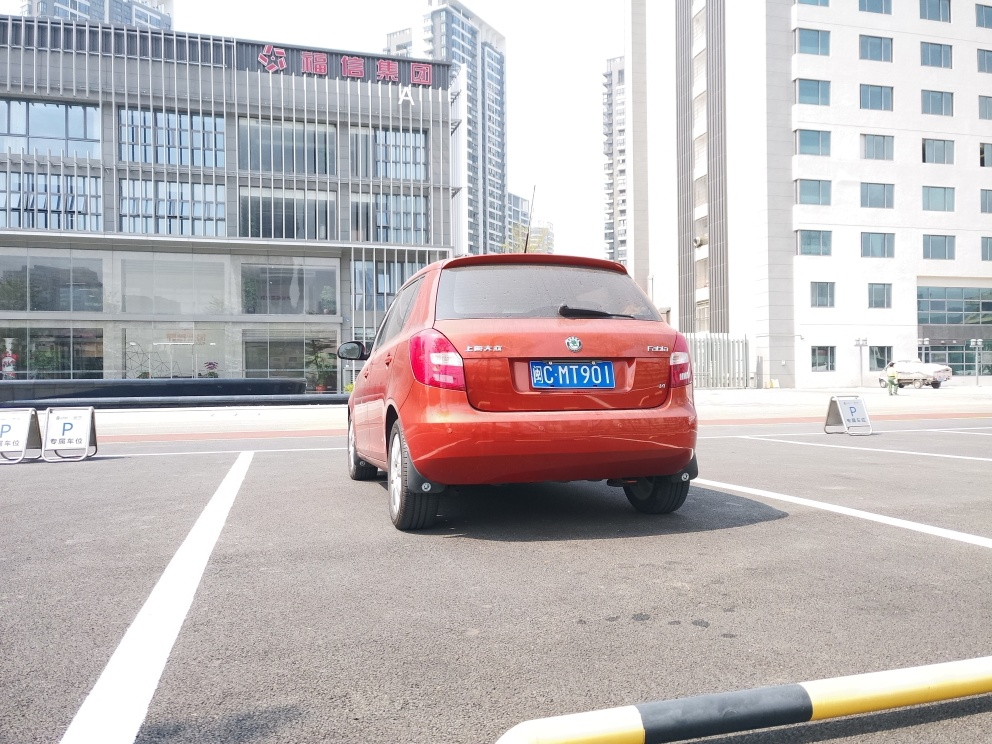Can you describe the setting of this photograph? The photograph captures a bright and clear day in an urban setting. A red hatchback car is parked in a marked bay within a spacious parking lot. The area appears to be part of a business district, given the modern buildings in the background that feature reflective glass facades. There are parking instructions and signs visible, indicating a well-organized space. The parking lot is delineated with white lines on a grey asphalt surface, and a curb with a yellow safety barrier is in the foreground. 